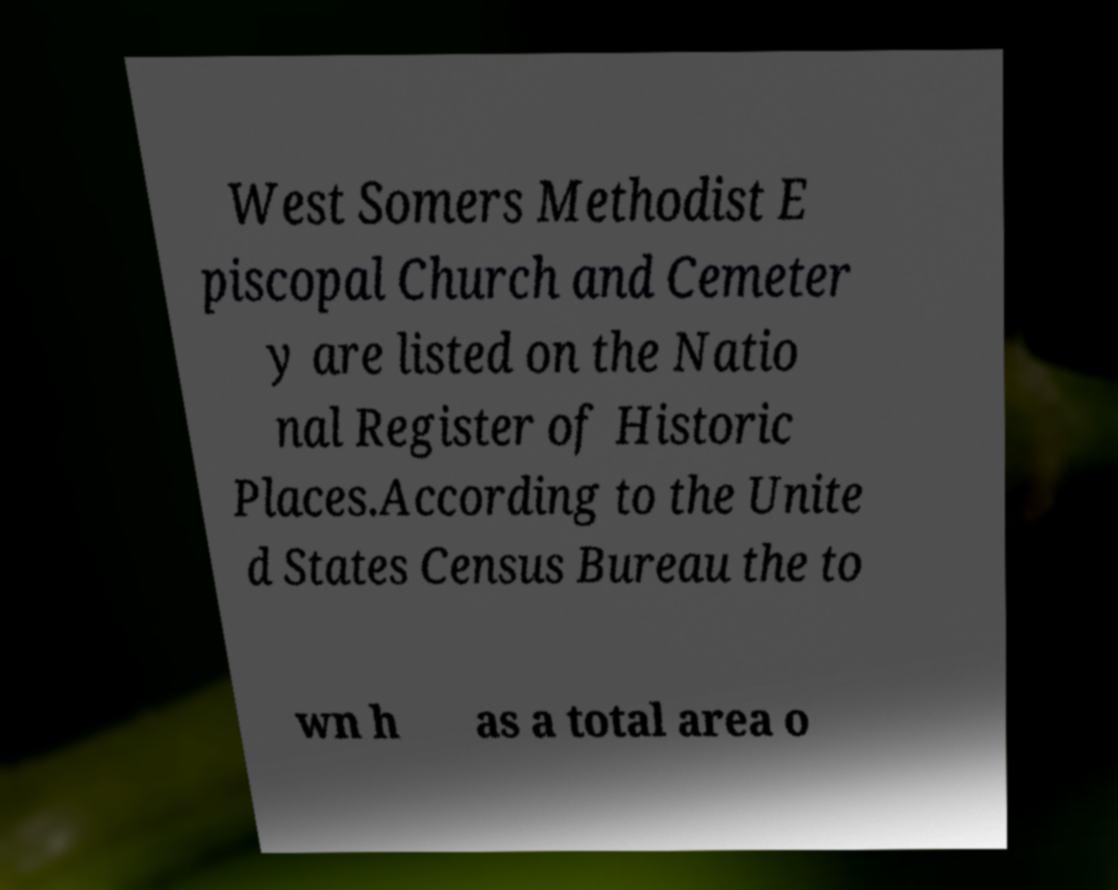Please identify and transcribe the text found in this image. West Somers Methodist E piscopal Church and Cemeter y are listed on the Natio nal Register of Historic Places.According to the Unite d States Census Bureau the to wn h as a total area o 